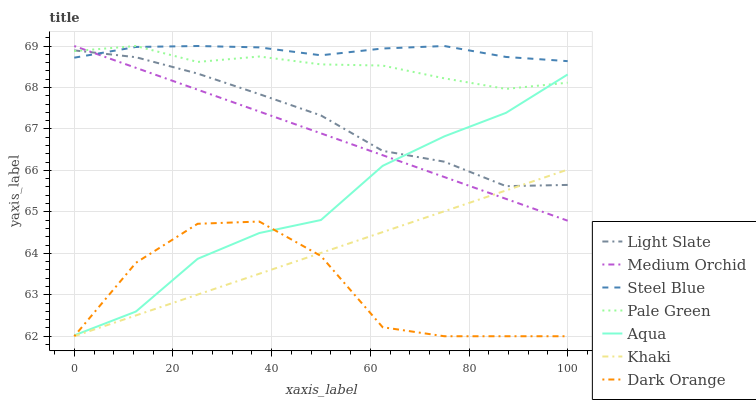Does Dark Orange have the minimum area under the curve?
Answer yes or no. Yes. Does Steel Blue have the maximum area under the curve?
Answer yes or no. Yes. Does Khaki have the minimum area under the curve?
Answer yes or no. No. Does Khaki have the maximum area under the curve?
Answer yes or no. No. Is Medium Orchid the smoothest?
Answer yes or no. Yes. Is Dark Orange the roughest?
Answer yes or no. Yes. Is Khaki the smoothest?
Answer yes or no. No. Is Khaki the roughest?
Answer yes or no. No. Does Dark Orange have the lowest value?
Answer yes or no. Yes. Does Light Slate have the lowest value?
Answer yes or no. No. Does Pale Green have the highest value?
Answer yes or no. Yes. Does Khaki have the highest value?
Answer yes or no. No. Is Khaki less than Steel Blue?
Answer yes or no. Yes. Is Steel Blue greater than Dark Orange?
Answer yes or no. Yes. Does Light Slate intersect Pale Green?
Answer yes or no. Yes. Is Light Slate less than Pale Green?
Answer yes or no. No. Is Light Slate greater than Pale Green?
Answer yes or no. No. Does Khaki intersect Steel Blue?
Answer yes or no. No. 